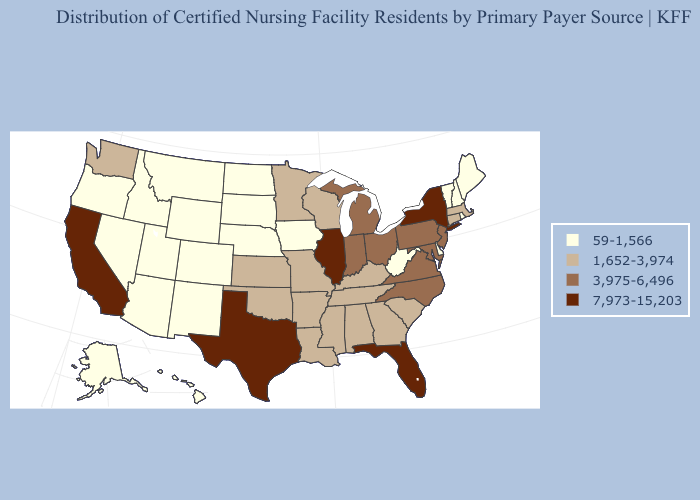Does Florida have the highest value in the USA?
Be succinct. Yes. What is the lowest value in states that border Utah?
Short answer required. 59-1,566. Name the states that have a value in the range 7,973-15,203?
Quick response, please. California, Florida, Illinois, New York, Texas. What is the lowest value in the USA?
Concise answer only. 59-1,566. Does Pennsylvania have a higher value than Texas?
Quick response, please. No. What is the value of California?
Keep it brief. 7,973-15,203. Does Utah have the lowest value in the West?
Keep it brief. Yes. How many symbols are there in the legend?
Give a very brief answer. 4. What is the value of Alaska?
Write a very short answer. 59-1,566. Name the states that have a value in the range 1,652-3,974?
Give a very brief answer. Alabama, Arkansas, Connecticut, Georgia, Kansas, Kentucky, Louisiana, Massachusetts, Minnesota, Mississippi, Missouri, Oklahoma, South Carolina, Tennessee, Washington, Wisconsin. Name the states that have a value in the range 1,652-3,974?
Answer briefly. Alabama, Arkansas, Connecticut, Georgia, Kansas, Kentucky, Louisiana, Massachusetts, Minnesota, Mississippi, Missouri, Oklahoma, South Carolina, Tennessee, Washington, Wisconsin. Does Nebraska have a higher value than Indiana?
Short answer required. No. Name the states that have a value in the range 1,652-3,974?
Give a very brief answer. Alabama, Arkansas, Connecticut, Georgia, Kansas, Kentucky, Louisiana, Massachusetts, Minnesota, Mississippi, Missouri, Oklahoma, South Carolina, Tennessee, Washington, Wisconsin. How many symbols are there in the legend?
Write a very short answer. 4. Among the states that border Idaho , which have the lowest value?
Quick response, please. Montana, Nevada, Oregon, Utah, Wyoming. 